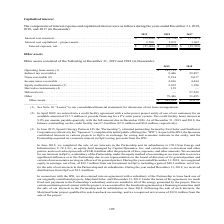According to First Solar's financial document, What is the interest rate on the credit facility agreement? According to the financial document, 8.0% per annum. The relevant text states: "wer system. The credit facility bears interest at 8.0% per annum, payable quarterly, with the full amount due in December 2026. As of December 31, 2019 and 2018, th..." Also, When did 8point3 Energy Partners LP complete its initial IPO? According to the financial document, June 2015. The relevant text states: "(3) In June 2015, 8point3 Energy Partners LP (the “Partnership”), a limited partnership formed by First Solar and Su..." Also, How much distribution was received from OpCo in 2018? According to the financial document, $12.4 million. The relevant text states: "r 31, 2018, we received distributions from OpCo of $12.4 million...." Also, can you calculate: What is the change in operating lease assets from 2018 to 2019? Based on the calculation: 145,711 - 0 , the result is 145711 (in thousands). This is based on the information: "2019 2018 2017 Interest cost incurred. . $ (29,656) $ (31,752) $ (27,457) Interest cost capitalized – 2019 2018 Operating lease assets (1). . $ 145,711 $ — Indirect tax receivables . 9,446 22,487 Note..." The key data points involved are: 0, 145,711. Also, can you calculate: How much did the deferred rent decrease from 2018 to 2019? Based on the calculation: 0 - 27,249 , the result is -27249 (in thousands). This is based on the information: "ivative instruments (4) . 139 — Deferred rent . — 27,249 Other . 79,446 33,495 Other assets . $ 249,854 $ 98,878 2019 2018 2017 Interest cost incurred. . $ (29,656) $ (31,752) $ (27,457) Interest cost..." The key data points involved are: 0, 27,249. Also, can you calculate: What is the percentage change in other assets from 2018 to 2019? To answer this question, I need to perform calculations using the financial data. The calculation is: (249,854 - 98,878) / 98,878 , which equals 152.69 (percentage). This is based on the information: ". — 27,249 Other . 79,446 33,495 Other assets . $ 249,854 $ 98,878 Other . 79,446 33,495 Other assets . $ 249,854 $ 98,878..." The key data points involved are: 249,854, 98,878. 